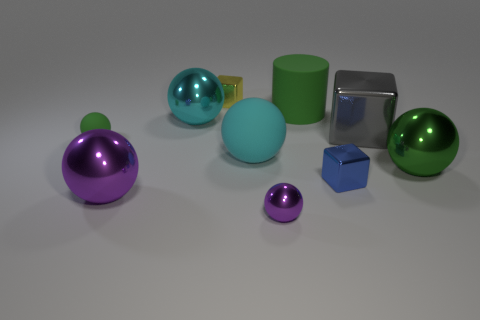Is the shape of the small blue metal object the same as the small yellow object?
Your response must be concise. Yes. How many objects are either cyan spheres that are to the right of the small yellow block or tiny shiny things in front of the big cyan metallic object?
Your response must be concise. 3. What number of objects are either small green objects or big gray shiny cubes?
Your response must be concise. 2. What number of gray blocks are to the right of the metallic block that is on the right side of the blue object?
Make the answer very short. 0. How many other things are there of the same size as the cyan rubber ball?
Offer a very short reply. 5. There is another matte thing that is the same color as the small matte thing; what is its size?
Provide a succinct answer. Large. Is the shape of the big matte thing behind the big gray thing the same as  the tiny yellow metal object?
Your answer should be compact. No. There is a cube that is in front of the big gray metallic cube; what is its material?
Give a very brief answer. Metal. What shape is the big object that is the same color as the tiny shiny ball?
Your answer should be compact. Sphere. Are there any other blue objects that have the same material as the blue object?
Offer a very short reply. No. 